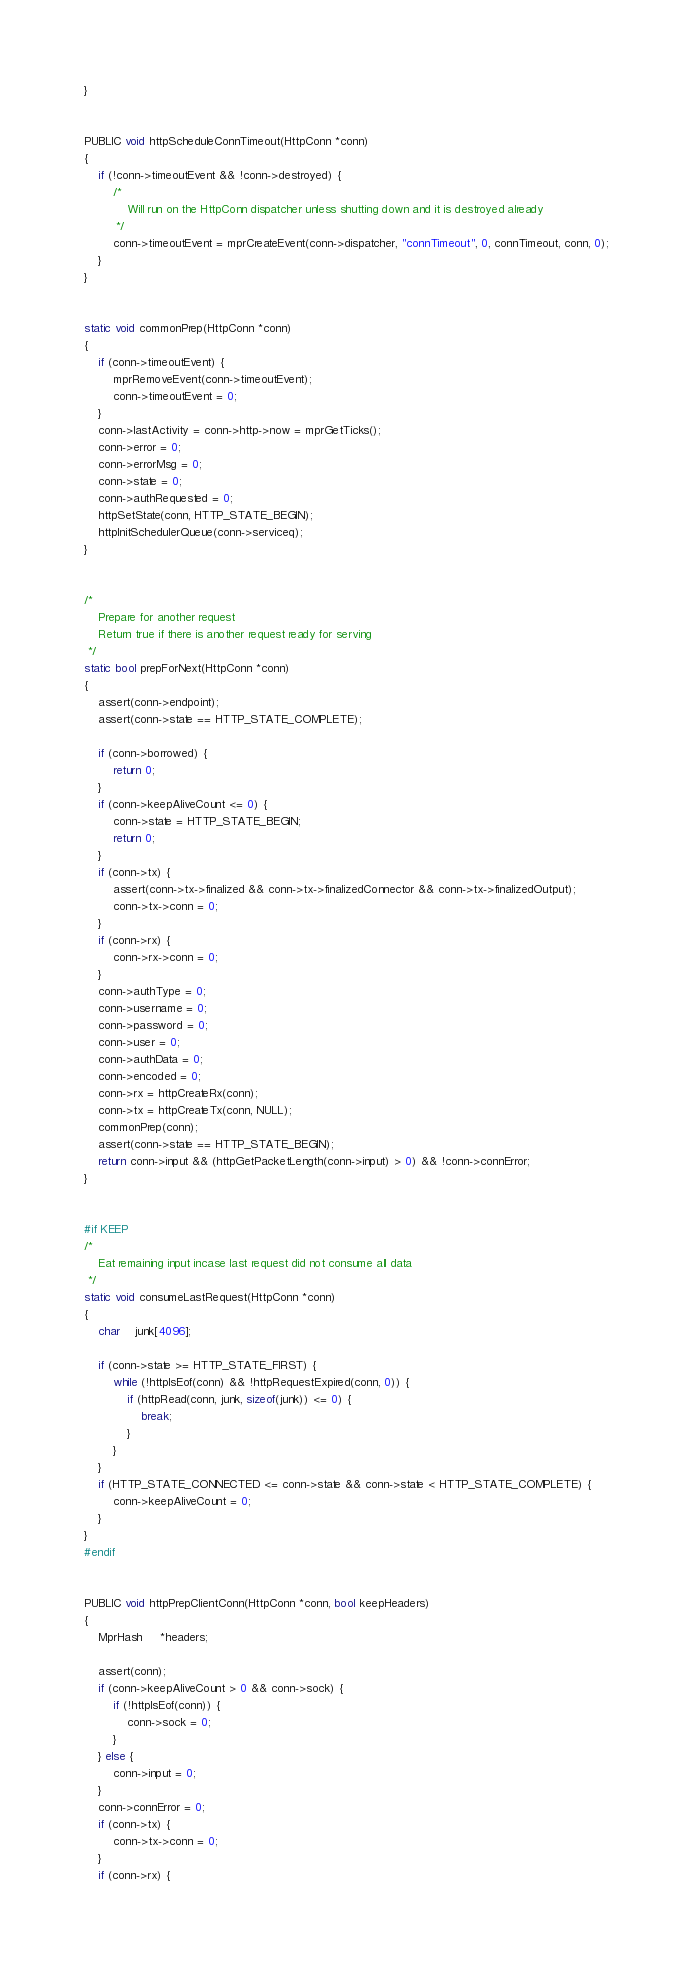<code> <loc_0><loc_0><loc_500><loc_500><_C_>}


PUBLIC void httpScheduleConnTimeout(HttpConn *conn)
{
    if (!conn->timeoutEvent && !conn->destroyed) {
        /*
            Will run on the HttpConn dispatcher unless shutting down and it is destroyed already
         */
        conn->timeoutEvent = mprCreateEvent(conn->dispatcher, "connTimeout", 0, connTimeout, conn, 0);
    }
}


static void commonPrep(HttpConn *conn)
{
    if (conn->timeoutEvent) {
        mprRemoveEvent(conn->timeoutEvent);
        conn->timeoutEvent = 0;
    }
    conn->lastActivity = conn->http->now = mprGetTicks();
    conn->error = 0;
    conn->errorMsg = 0;
    conn->state = 0;
    conn->authRequested = 0;
    httpSetState(conn, HTTP_STATE_BEGIN);
    httpInitSchedulerQueue(conn->serviceq);
}


/*
    Prepare for another request
    Return true if there is another request ready for serving
 */
static bool prepForNext(HttpConn *conn)
{
    assert(conn->endpoint);
    assert(conn->state == HTTP_STATE_COMPLETE);

    if (conn->borrowed) {
        return 0;
    }
    if (conn->keepAliveCount <= 0) {
        conn->state = HTTP_STATE_BEGIN;
        return 0;
    }
    if (conn->tx) {
        assert(conn->tx->finalized && conn->tx->finalizedConnector && conn->tx->finalizedOutput);
        conn->tx->conn = 0;
    }
    if (conn->rx) {
        conn->rx->conn = 0;
    }
    conn->authType = 0;
    conn->username = 0;
    conn->password = 0;
    conn->user = 0;
    conn->authData = 0;
    conn->encoded = 0;
    conn->rx = httpCreateRx(conn);
    conn->tx = httpCreateTx(conn, NULL);
    commonPrep(conn);
    assert(conn->state == HTTP_STATE_BEGIN);
    return conn->input && (httpGetPacketLength(conn->input) > 0) && !conn->connError;
}


#if KEEP
/*
    Eat remaining input incase last request did not consume all data
 */
static void consumeLastRequest(HttpConn *conn)
{
    char    junk[4096];

    if (conn->state >= HTTP_STATE_FIRST) {
        while (!httpIsEof(conn) && !httpRequestExpired(conn, 0)) {
            if (httpRead(conn, junk, sizeof(junk)) <= 0) {
                break;
            }
        }
    }
    if (HTTP_STATE_CONNECTED <= conn->state && conn->state < HTTP_STATE_COMPLETE) {
        conn->keepAliveCount = 0;
    }
}
#endif


PUBLIC void httpPrepClientConn(HttpConn *conn, bool keepHeaders)
{
    MprHash     *headers;

    assert(conn);
    if (conn->keepAliveCount > 0 && conn->sock) {
        if (!httpIsEof(conn)) {
            conn->sock = 0;
        }
    } else {
        conn->input = 0;
    }
    conn->connError = 0;
    if (conn->tx) {
        conn->tx->conn = 0;
    }
    if (conn->rx) {</code> 